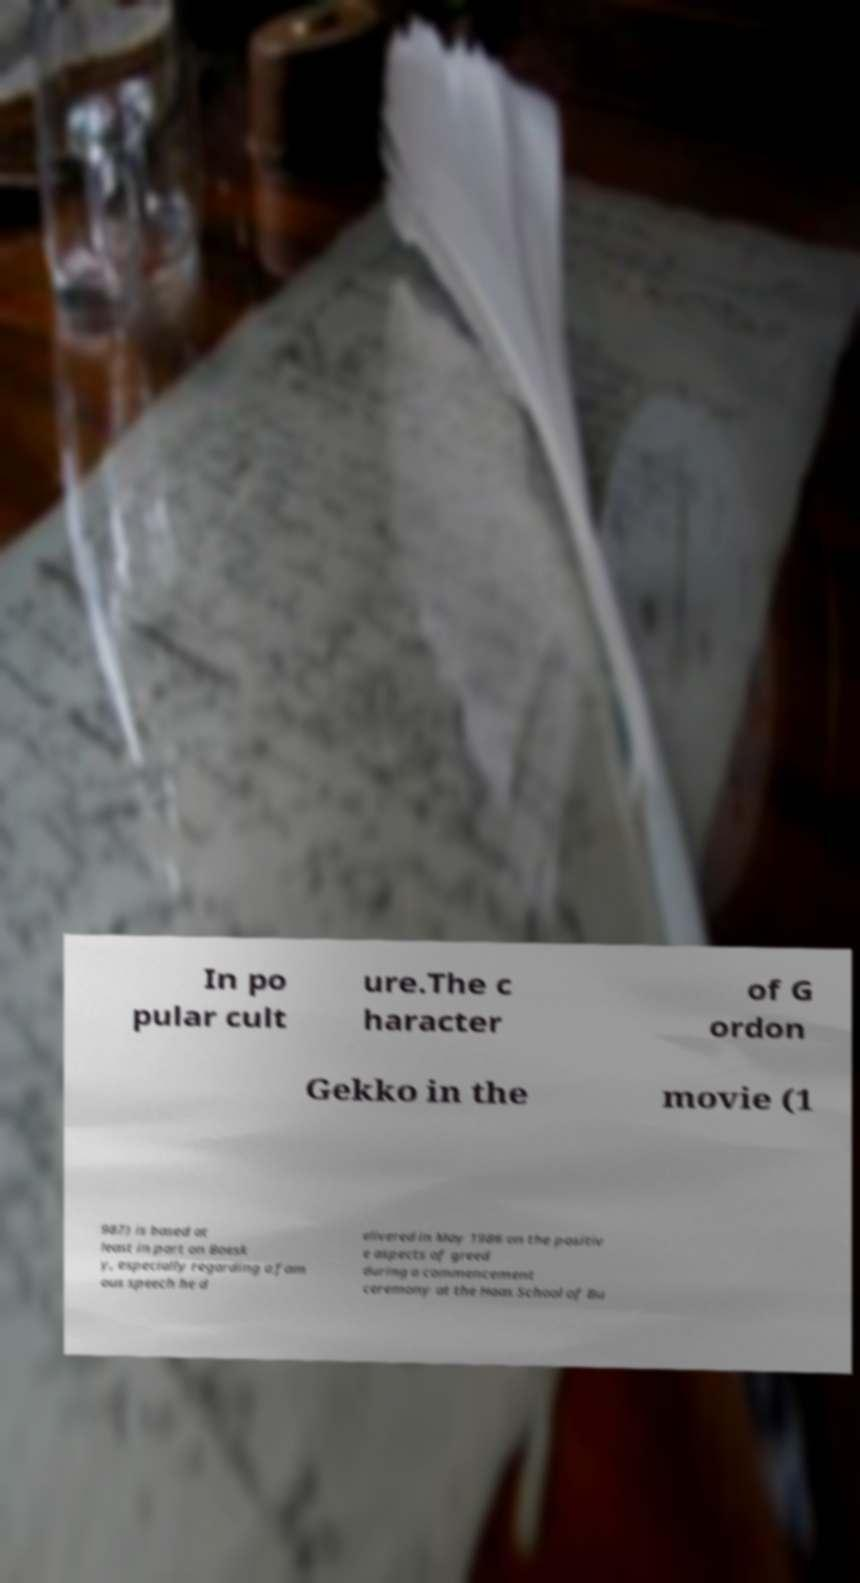There's text embedded in this image that I need extracted. Can you transcribe it verbatim? In po pular cult ure.The c haracter of G ordon Gekko in the movie (1 987) is based at least in part on Boesk y, especially regarding a fam ous speech he d elivered in May 1986 on the positiv e aspects of greed during a commencement ceremony at the Haas School of Bu 